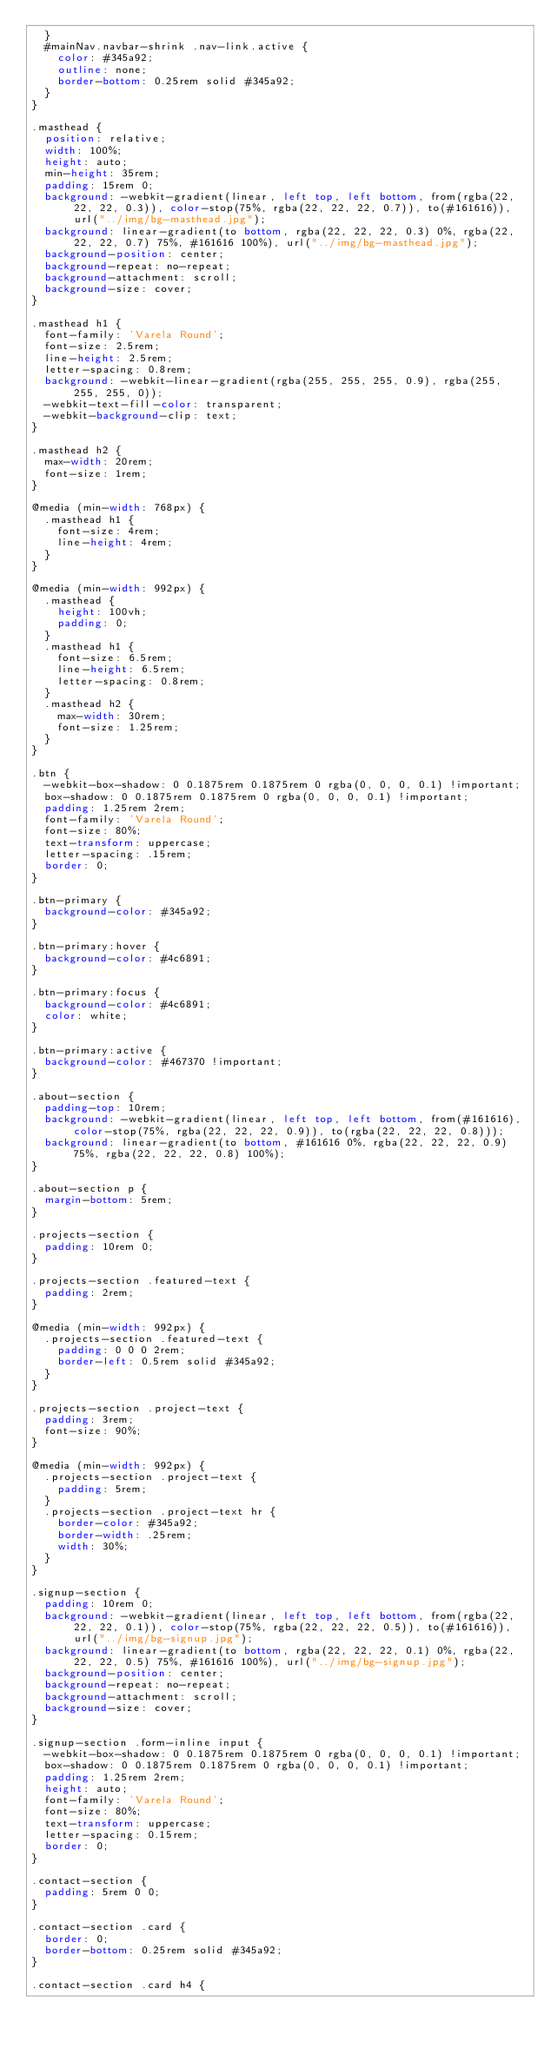Convert code to text. <code><loc_0><loc_0><loc_500><loc_500><_CSS_>  }
  #mainNav.navbar-shrink .nav-link.active {
    color: #345a92;
    outline: none;
    border-bottom: 0.25rem solid #345a92;
  }
}

.masthead {
  position: relative;
  width: 100%;
  height: auto;
  min-height: 35rem;
  padding: 15rem 0;
  background: -webkit-gradient(linear, left top, left bottom, from(rgba(22, 22, 22, 0.3)), color-stop(75%, rgba(22, 22, 22, 0.7)), to(#161616)), url("../img/bg-masthead.jpg");
  background: linear-gradient(to bottom, rgba(22, 22, 22, 0.3) 0%, rgba(22, 22, 22, 0.7) 75%, #161616 100%), url("../img/bg-masthead.jpg");
  background-position: center;
  background-repeat: no-repeat;
  background-attachment: scroll;
  background-size: cover;
}

.masthead h1 {
  font-family: 'Varela Round';
  font-size: 2.5rem;
  line-height: 2.5rem;
  letter-spacing: 0.8rem;
  background: -webkit-linear-gradient(rgba(255, 255, 255, 0.9), rgba(255, 255, 255, 0));
  -webkit-text-fill-color: transparent;
  -webkit-background-clip: text;
}

.masthead h2 {
  max-width: 20rem;
  font-size: 1rem;
}

@media (min-width: 768px) {
  .masthead h1 {
    font-size: 4rem;
    line-height: 4rem;
  }
}

@media (min-width: 992px) {
  .masthead {
    height: 100vh;
    padding: 0;
  }
  .masthead h1 {
    font-size: 6.5rem;
    line-height: 6.5rem;
    letter-spacing: 0.8rem;
  }
  .masthead h2 {
    max-width: 30rem;
    font-size: 1.25rem;
  }
}

.btn {
  -webkit-box-shadow: 0 0.1875rem 0.1875rem 0 rgba(0, 0, 0, 0.1) !important;
  box-shadow: 0 0.1875rem 0.1875rem 0 rgba(0, 0, 0, 0.1) !important;
  padding: 1.25rem 2rem;
  font-family: 'Varela Round';
  font-size: 80%;
  text-transform: uppercase;
  letter-spacing: .15rem;
  border: 0;
}

.btn-primary {
  background-color: #345a92;
}

.btn-primary:hover {
  background-color: #4c6891;
}

.btn-primary:focus {
  background-color: #4c6891;
  color: white;
}

.btn-primary:active {
  background-color: #467370 !important;
}

.about-section {
  padding-top: 10rem;
  background: -webkit-gradient(linear, left top, left bottom, from(#161616), color-stop(75%, rgba(22, 22, 22, 0.9)), to(rgba(22, 22, 22, 0.8)));
  background: linear-gradient(to bottom, #161616 0%, rgba(22, 22, 22, 0.9) 75%, rgba(22, 22, 22, 0.8) 100%);
}

.about-section p {
  margin-bottom: 5rem;
}

.projects-section {
  padding: 10rem 0;
}

.projects-section .featured-text {
  padding: 2rem;
}

@media (min-width: 992px) {
  .projects-section .featured-text {
    padding: 0 0 0 2rem;
    border-left: 0.5rem solid #345a92;
  }
}

.projects-section .project-text {
  padding: 3rem;
  font-size: 90%;
}

@media (min-width: 992px) {
  .projects-section .project-text {
    padding: 5rem;
  }
  .projects-section .project-text hr {
    border-color: #345a92;
    border-width: .25rem;
    width: 30%;
  }
}

.signup-section {
  padding: 10rem 0;
  background: -webkit-gradient(linear, left top, left bottom, from(rgba(22, 22, 22, 0.1)), color-stop(75%, rgba(22, 22, 22, 0.5)), to(#161616)), url("../img/bg-signup.jpg");
  background: linear-gradient(to bottom, rgba(22, 22, 22, 0.1) 0%, rgba(22, 22, 22, 0.5) 75%, #161616 100%), url("../img/bg-signup.jpg");
  background-position: center;
  background-repeat: no-repeat;
  background-attachment: scroll;
  background-size: cover;
}

.signup-section .form-inline input {
  -webkit-box-shadow: 0 0.1875rem 0.1875rem 0 rgba(0, 0, 0, 0.1) !important;
  box-shadow: 0 0.1875rem 0.1875rem 0 rgba(0, 0, 0, 0.1) !important;
  padding: 1.25rem 2rem;
  height: auto;
  font-family: 'Varela Round';
  font-size: 80%;
  text-transform: uppercase;
  letter-spacing: 0.15rem;
  border: 0;
}

.contact-section {
  padding: 5rem 0 0;
}

.contact-section .card {
  border: 0;
  border-bottom: 0.25rem solid #345a92;
}

.contact-section .card h4 {</code> 